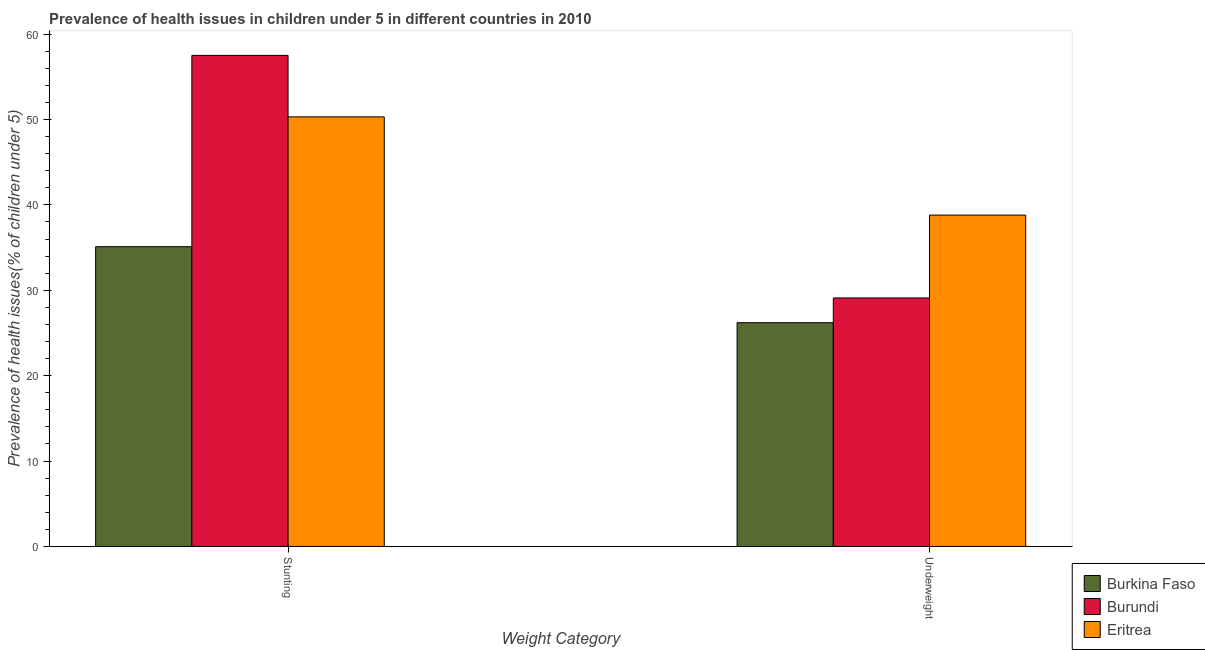Are the number of bars per tick equal to the number of legend labels?
Offer a very short reply. Yes. Are the number of bars on each tick of the X-axis equal?
Keep it short and to the point. Yes. How many bars are there on the 2nd tick from the right?
Your answer should be compact. 3. What is the label of the 2nd group of bars from the left?
Provide a short and direct response. Underweight. What is the percentage of stunted children in Burundi?
Offer a very short reply. 57.5. Across all countries, what is the maximum percentage of stunted children?
Give a very brief answer. 57.5. Across all countries, what is the minimum percentage of underweight children?
Your answer should be compact. 26.2. In which country was the percentage of underweight children maximum?
Your response must be concise. Eritrea. In which country was the percentage of stunted children minimum?
Ensure brevity in your answer.  Burkina Faso. What is the total percentage of underweight children in the graph?
Your response must be concise. 94.1. What is the difference between the percentage of stunted children in Burkina Faso and that in Burundi?
Offer a very short reply. -22.4. What is the difference between the percentage of underweight children in Burundi and the percentage of stunted children in Burkina Faso?
Make the answer very short. -6. What is the average percentage of stunted children per country?
Make the answer very short. 47.63. What is the difference between the percentage of stunted children and percentage of underweight children in Eritrea?
Provide a succinct answer. 11.5. What is the ratio of the percentage of underweight children in Burundi to that in Eritrea?
Your answer should be compact. 0.75. Is the percentage of underweight children in Burkina Faso less than that in Eritrea?
Your answer should be very brief. Yes. What does the 2nd bar from the left in Stunting represents?
Ensure brevity in your answer.  Burundi. What does the 2nd bar from the right in Underweight represents?
Give a very brief answer. Burundi. Are all the bars in the graph horizontal?
Provide a short and direct response. No. What is the difference between two consecutive major ticks on the Y-axis?
Your answer should be very brief. 10. Are the values on the major ticks of Y-axis written in scientific E-notation?
Your response must be concise. No. Does the graph contain any zero values?
Offer a very short reply. No. Where does the legend appear in the graph?
Provide a succinct answer. Bottom right. How are the legend labels stacked?
Offer a terse response. Vertical. What is the title of the graph?
Give a very brief answer. Prevalence of health issues in children under 5 in different countries in 2010. Does "United States" appear as one of the legend labels in the graph?
Your response must be concise. No. What is the label or title of the X-axis?
Your response must be concise. Weight Category. What is the label or title of the Y-axis?
Ensure brevity in your answer.  Prevalence of health issues(% of children under 5). What is the Prevalence of health issues(% of children under 5) of Burkina Faso in Stunting?
Keep it short and to the point. 35.1. What is the Prevalence of health issues(% of children under 5) of Burundi in Stunting?
Offer a very short reply. 57.5. What is the Prevalence of health issues(% of children under 5) in Eritrea in Stunting?
Provide a succinct answer. 50.3. What is the Prevalence of health issues(% of children under 5) in Burkina Faso in Underweight?
Provide a succinct answer. 26.2. What is the Prevalence of health issues(% of children under 5) of Burundi in Underweight?
Your response must be concise. 29.1. What is the Prevalence of health issues(% of children under 5) in Eritrea in Underweight?
Make the answer very short. 38.8. Across all Weight Category, what is the maximum Prevalence of health issues(% of children under 5) of Burkina Faso?
Your response must be concise. 35.1. Across all Weight Category, what is the maximum Prevalence of health issues(% of children under 5) in Burundi?
Your response must be concise. 57.5. Across all Weight Category, what is the maximum Prevalence of health issues(% of children under 5) in Eritrea?
Your answer should be compact. 50.3. Across all Weight Category, what is the minimum Prevalence of health issues(% of children under 5) in Burkina Faso?
Your answer should be very brief. 26.2. Across all Weight Category, what is the minimum Prevalence of health issues(% of children under 5) of Burundi?
Make the answer very short. 29.1. Across all Weight Category, what is the minimum Prevalence of health issues(% of children under 5) of Eritrea?
Provide a succinct answer. 38.8. What is the total Prevalence of health issues(% of children under 5) in Burkina Faso in the graph?
Your answer should be compact. 61.3. What is the total Prevalence of health issues(% of children under 5) of Burundi in the graph?
Ensure brevity in your answer.  86.6. What is the total Prevalence of health issues(% of children under 5) of Eritrea in the graph?
Provide a short and direct response. 89.1. What is the difference between the Prevalence of health issues(% of children under 5) in Burkina Faso in Stunting and that in Underweight?
Offer a very short reply. 8.9. What is the difference between the Prevalence of health issues(% of children under 5) in Burundi in Stunting and that in Underweight?
Provide a succinct answer. 28.4. What is the difference between the Prevalence of health issues(% of children under 5) in Burkina Faso in Stunting and the Prevalence of health issues(% of children under 5) in Eritrea in Underweight?
Keep it short and to the point. -3.7. What is the average Prevalence of health issues(% of children under 5) of Burkina Faso per Weight Category?
Your answer should be very brief. 30.65. What is the average Prevalence of health issues(% of children under 5) in Burundi per Weight Category?
Your answer should be very brief. 43.3. What is the average Prevalence of health issues(% of children under 5) of Eritrea per Weight Category?
Offer a terse response. 44.55. What is the difference between the Prevalence of health issues(% of children under 5) of Burkina Faso and Prevalence of health issues(% of children under 5) of Burundi in Stunting?
Give a very brief answer. -22.4. What is the difference between the Prevalence of health issues(% of children under 5) in Burkina Faso and Prevalence of health issues(% of children under 5) in Eritrea in Stunting?
Your answer should be very brief. -15.2. What is the difference between the Prevalence of health issues(% of children under 5) in Burkina Faso and Prevalence of health issues(% of children under 5) in Burundi in Underweight?
Your response must be concise. -2.9. What is the difference between the Prevalence of health issues(% of children under 5) of Burkina Faso and Prevalence of health issues(% of children under 5) of Eritrea in Underweight?
Keep it short and to the point. -12.6. What is the difference between the Prevalence of health issues(% of children under 5) in Burundi and Prevalence of health issues(% of children under 5) in Eritrea in Underweight?
Provide a short and direct response. -9.7. What is the ratio of the Prevalence of health issues(% of children under 5) in Burkina Faso in Stunting to that in Underweight?
Ensure brevity in your answer.  1.34. What is the ratio of the Prevalence of health issues(% of children under 5) of Burundi in Stunting to that in Underweight?
Your answer should be compact. 1.98. What is the ratio of the Prevalence of health issues(% of children under 5) in Eritrea in Stunting to that in Underweight?
Provide a succinct answer. 1.3. What is the difference between the highest and the second highest Prevalence of health issues(% of children under 5) of Burundi?
Offer a terse response. 28.4. What is the difference between the highest and the second highest Prevalence of health issues(% of children under 5) in Eritrea?
Offer a very short reply. 11.5. What is the difference between the highest and the lowest Prevalence of health issues(% of children under 5) of Burkina Faso?
Your response must be concise. 8.9. What is the difference between the highest and the lowest Prevalence of health issues(% of children under 5) in Burundi?
Your response must be concise. 28.4. What is the difference between the highest and the lowest Prevalence of health issues(% of children under 5) in Eritrea?
Offer a very short reply. 11.5. 